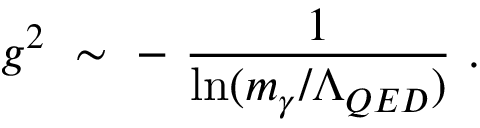<formula> <loc_0><loc_0><loc_500><loc_500>g ^ { 2 } \ \sim \ - \ \frac { 1 } \ln ( m _ { \gamma } / \Lambda _ { Q E D } ) } \ .</formula> 